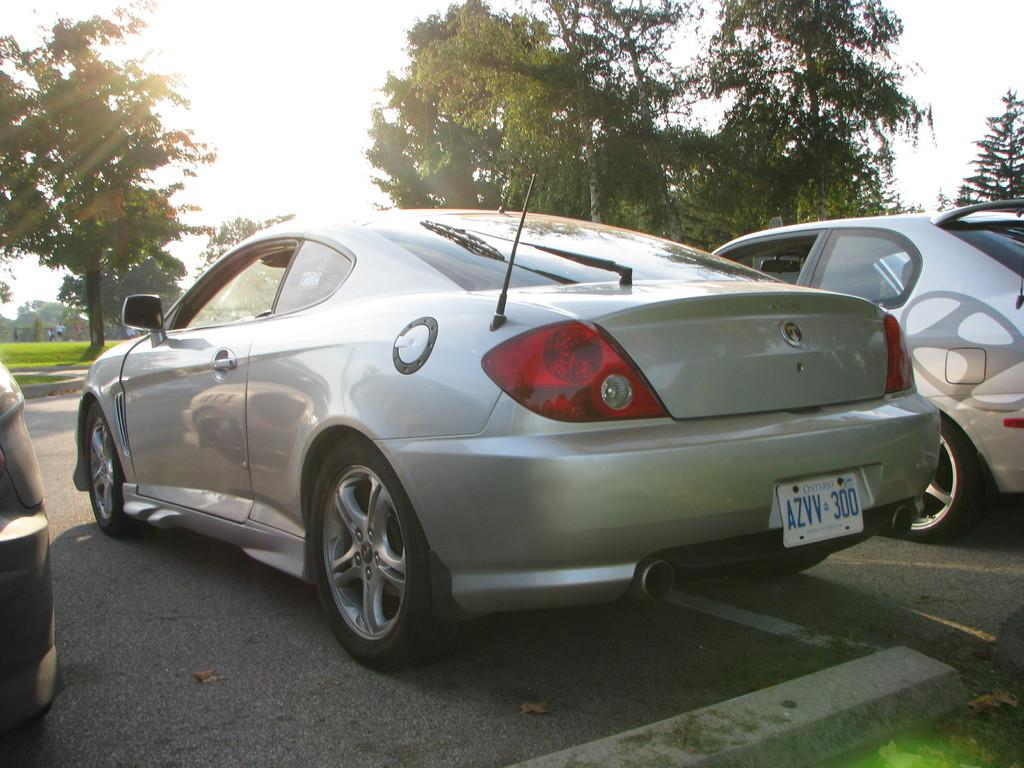What can be seen parked in the image? There are cars parked in the image. What is visible in the background of the image? There are trees and persons in the background of the image. What type of vegetation is present in the background? The ground appears to be green and grassy in the background. Can you tell me how many writers are visible in the image? There is no writer present in the image; it features parked cars, trees, persons, and a green, grassy background. 